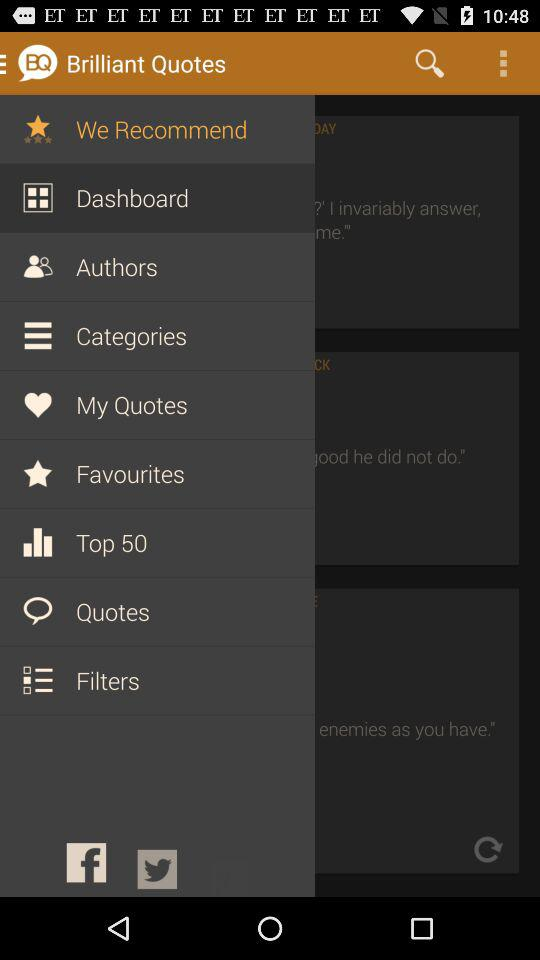What is the name of the application? The name of the application is "Brilliant Quotes". 